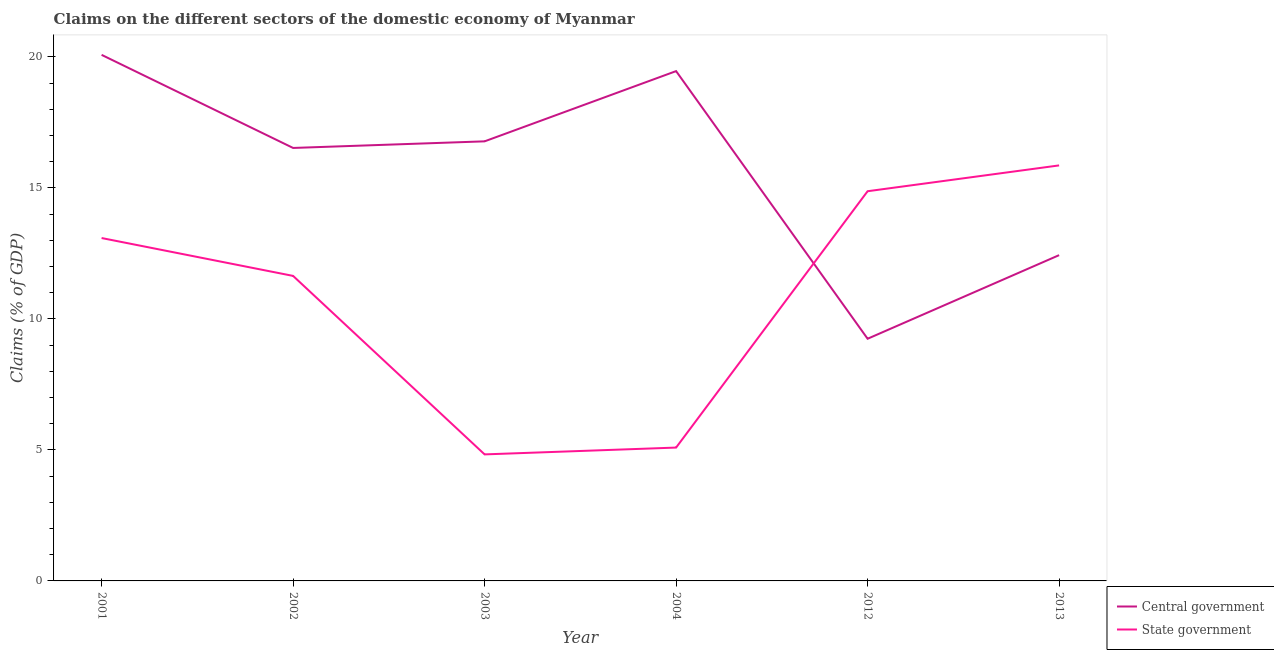Does the line corresponding to claims on state government intersect with the line corresponding to claims on central government?
Keep it short and to the point. Yes. What is the claims on central government in 2001?
Provide a succinct answer. 20.08. Across all years, what is the maximum claims on central government?
Offer a terse response. 20.08. Across all years, what is the minimum claims on state government?
Provide a short and direct response. 4.83. What is the total claims on state government in the graph?
Keep it short and to the point. 65.39. What is the difference between the claims on state government in 2004 and that in 2012?
Provide a succinct answer. -9.79. What is the difference between the claims on state government in 2012 and the claims on central government in 2001?
Your response must be concise. -5.21. What is the average claims on state government per year?
Provide a short and direct response. 10.9. In the year 2012, what is the difference between the claims on state government and claims on central government?
Offer a terse response. 5.63. What is the ratio of the claims on state government in 2003 to that in 2012?
Keep it short and to the point. 0.32. Is the claims on state government in 2002 less than that in 2003?
Your answer should be very brief. No. What is the difference between the highest and the second highest claims on central government?
Offer a very short reply. 0.62. What is the difference between the highest and the lowest claims on central government?
Ensure brevity in your answer.  10.84. In how many years, is the claims on central government greater than the average claims on central government taken over all years?
Ensure brevity in your answer.  4. Is the sum of the claims on central government in 2012 and 2013 greater than the maximum claims on state government across all years?
Provide a short and direct response. Yes. Does the claims on central government monotonically increase over the years?
Your answer should be very brief. No. How many years are there in the graph?
Offer a very short reply. 6. Does the graph contain any zero values?
Give a very brief answer. No. Where does the legend appear in the graph?
Your response must be concise. Bottom right. How are the legend labels stacked?
Your answer should be very brief. Vertical. What is the title of the graph?
Offer a very short reply. Claims on the different sectors of the domestic economy of Myanmar. Does "Current education expenditure" appear as one of the legend labels in the graph?
Offer a terse response. No. What is the label or title of the X-axis?
Provide a short and direct response. Year. What is the label or title of the Y-axis?
Provide a short and direct response. Claims (% of GDP). What is the Claims (% of GDP) of Central government in 2001?
Make the answer very short. 20.08. What is the Claims (% of GDP) of State government in 2001?
Ensure brevity in your answer.  13.09. What is the Claims (% of GDP) of Central government in 2002?
Make the answer very short. 16.53. What is the Claims (% of GDP) of State government in 2002?
Keep it short and to the point. 11.64. What is the Claims (% of GDP) of Central government in 2003?
Provide a short and direct response. 16.78. What is the Claims (% of GDP) in State government in 2003?
Make the answer very short. 4.83. What is the Claims (% of GDP) of Central government in 2004?
Offer a very short reply. 19.46. What is the Claims (% of GDP) of State government in 2004?
Keep it short and to the point. 5.09. What is the Claims (% of GDP) of Central government in 2012?
Make the answer very short. 9.24. What is the Claims (% of GDP) in State government in 2012?
Your answer should be very brief. 14.88. What is the Claims (% of GDP) of Central government in 2013?
Keep it short and to the point. 12.44. What is the Claims (% of GDP) of State government in 2013?
Provide a succinct answer. 15.86. Across all years, what is the maximum Claims (% of GDP) of Central government?
Make the answer very short. 20.08. Across all years, what is the maximum Claims (% of GDP) in State government?
Your answer should be very brief. 15.86. Across all years, what is the minimum Claims (% of GDP) of Central government?
Offer a very short reply. 9.24. Across all years, what is the minimum Claims (% of GDP) of State government?
Offer a terse response. 4.83. What is the total Claims (% of GDP) in Central government in the graph?
Offer a very short reply. 94.53. What is the total Claims (% of GDP) in State government in the graph?
Offer a very short reply. 65.39. What is the difference between the Claims (% of GDP) of Central government in 2001 and that in 2002?
Give a very brief answer. 3.55. What is the difference between the Claims (% of GDP) of State government in 2001 and that in 2002?
Offer a terse response. 1.45. What is the difference between the Claims (% of GDP) of Central government in 2001 and that in 2003?
Your response must be concise. 3.3. What is the difference between the Claims (% of GDP) in State government in 2001 and that in 2003?
Make the answer very short. 8.26. What is the difference between the Claims (% of GDP) of Central government in 2001 and that in 2004?
Keep it short and to the point. 0.62. What is the difference between the Claims (% of GDP) of State government in 2001 and that in 2004?
Your answer should be very brief. 8. What is the difference between the Claims (% of GDP) of Central government in 2001 and that in 2012?
Offer a terse response. 10.84. What is the difference between the Claims (% of GDP) of State government in 2001 and that in 2012?
Ensure brevity in your answer.  -1.79. What is the difference between the Claims (% of GDP) of Central government in 2001 and that in 2013?
Offer a terse response. 7.65. What is the difference between the Claims (% of GDP) in State government in 2001 and that in 2013?
Provide a succinct answer. -2.77. What is the difference between the Claims (% of GDP) of Central government in 2002 and that in 2003?
Keep it short and to the point. -0.25. What is the difference between the Claims (% of GDP) in State government in 2002 and that in 2003?
Provide a succinct answer. 6.81. What is the difference between the Claims (% of GDP) of Central government in 2002 and that in 2004?
Ensure brevity in your answer.  -2.93. What is the difference between the Claims (% of GDP) in State government in 2002 and that in 2004?
Provide a succinct answer. 6.55. What is the difference between the Claims (% of GDP) of Central government in 2002 and that in 2012?
Provide a short and direct response. 7.28. What is the difference between the Claims (% of GDP) in State government in 2002 and that in 2012?
Your answer should be compact. -3.23. What is the difference between the Claims (% of GDP) in Central government in 2002 and that in 2013?
Provide a short and direct response. 4.09. What is the difference between the Claims (% of GDP) of State government in 2002 and that in 2013?
Provide a short and direct response. -4.22. What is the difference between the Claims (% of GDP) of Central government in 2003 and that in 2004?
Your response must be concise. -2.68. What is the difference between the Claims (% of GDP) of State government in 2003 and that in 2004?
Ensure brevity in your answer.  -0.26. What is the difference between the Claims (% of GDP) in Central government in 2003 and that in 2012?
Your response must be concise. 7.54. What is the difference between the Claims (% of GDP) in State government in 2003 and that in 2012?
Your answer should be compact. -10.05. What is the difference between the Claims (% of GDP) in Central government in 2003 and that in 2013?
Your answer should be very brief. 4.34. What is the difference between the Claims (% of GDP) in State government in 2003 and that in 2013?
Offer a terse response. -11.03. What is the difference between the Claims (% of GDP) of Central government in 2004 and that in 2012?
Provide a succinct answer. 10.22. What is the difference between the Claims (% of GDP) of State government in 2004 and that in 2012?
Ensure brevity in your answer.  -9.79. What is the difference between the Claims (% of GDP) in Central government in 2004 and that in 2013?
Keep it short and to the point. 7.03. What is the difference between the Claims (% of GDP) in State government in 2004 and that in 2013?
Keep it short and to the point. -10.77. What is the difference between the Claims (% of GDP) in Central government in 2012 and that in 2013?
Give a very brief answer. -3.19. What is the difference between the Claims (% of GDP) of State government in 2012 and that in 2013?
Make the answer very short. -0.99. What is the difference between the Claims (% of GDP) in Central government in 2001 and the Claims (% of GDP) in State government in 2002?
Give a very brief answer. 8.44. What is the difference between the Claims (% of GDP) of Central government in 2001 and the Claims (% of GDP) of State government in 2003?
Provide a short and direct response. 15.25. What is the difference between the Claims (% of GDP) in Central government in 2001 and the Claims (% of GDP) in State government in 2004?
Provide a succinct answer. 14.99. What is the difference between the Claims (% of GDP) in Central government in 2001 and the Claims (% of GDP) in State government in 2012?
Your answer should be compact. 5.21. What is the difference between the Claims (% of GDP) of Central government in 2001 and the Claims (% of GDP) of State government in 2013?
Ensure brevity in your answer.  4.22. What is the difference between the Claims (% of GDP) of Central government in 2002 and the Claims (% of GDP) of State government in 2003?
Provide a short and direct response. 11.7. What is the difference between the Claims (% of GDP) of Central government in 2002 and the Claims (% of GDP) of State government in 2004?
Your answer should be compact. 11.44. What is the difference between the Claims (% of GDP) of Central government in 2002 and the Claims (% of GDP) of State government in 2012?
Offer a terse response. 1.65. What is the difference between the Claims (% of GDP) in Central government in 2002 and the Claims (% of GDP) in State government in 2013?
Your answer should be compact. 0.67. What is the difference between the Claims (% of GDP) of Central government in 2003 and the Claims (% of GDP) of State government in 2004?
Your response must be concise. 11.69. What is the difference between the Claims (% of GDP) of Central government in 2003 and the Claims (% of GDP) of State government in 2012?
Offer a terse response. 1.9. What is the difference between the Claims (% of GDP) in Central government in 2003 and the Claims (% of GDP) in State government in 2013?
Ensure brevity in your answer.  0.92. What is the difference between the Claims (% of GDP) in Central government in 2004 and the Claims (% of GDP) in State government in 2012?
Make the answer very short. 4.59. What is the difference between the Claims (% of GDP) of Central government in 2004 and the Claims (% of GDP) of State government in 2013?
Your answer should be very brief. 3.6. What is the difference between the Claims (% of GDP) in Central government in 2012 and the Claims (% of GDP) in State government in 2013?
Ensure brevity in your answer.  -6.62. What is the average Claims (% of GDP) in Central government per year?
Keep it short and to the point. 15.76. What is the average Claims (% of GDP) in State government per year?
Keep it short and to the point. 10.9. In the year 2001, what is the difference between the Claims (% of GDP) in Central government and Claims (% of GDP) in State government?
Provide a succinct answer. 6.99. In the year 2002, what is the difference between the Claims (% of GDP) of Central government and Claims (% of GDP) of State government?
Your answer should be compact. 4.88. In the year 2003, what is the difference between the Claims (% of GDP) of Central government and Claims (% of GDP) of State government?
Give a very brief answer. 11.95. In the year 2004, what is the difference between the Claims (% of GDP) of Central government and Claims (% of GDP) of State government?
Keep it short and to the point. 14.37. In the year 2012, what is the difference between the Claims (% of GDP) of Central government and Claims (% of GDP) of State government?
Give a very brief answer. -5.63. In the year 2013, what is the difference between the Claims (% of GDP) of Central government and Claims (% of GDP) of State government?
Your answer should be compact. -3.43. What is the ratio of the Claims (% of GDP) in Central government in 2001 to that in 2002?
Offer a very short reply. 1.22. What is the ratio of the Claims (% of GDP) of State government in 2001 to that in 2002?
Give a very brief answer. 1.12. What is the ratio of the Claims (% of GDP) of Central government in 2001 to that in 2003?
Make the answer very short. 1.2. What is the ratio of the Claims (% of GDP) in State government in 2001 to that in 2003?
Make the answer very short. 2.71. What is the ratio of the Claims (% of GDP) in Central government in 2001 to that in 2004?
Keep it short and to the point. 1.03. What is the ratio of the Claims (% of GDP) in State government in 2001 to that in 2004?
Offer a terse response. 2.57. What is the ratio of the Claims (% of GDP) in Central government in 2001 to that in 2012?
Your answer should be very brief. 2.17. What is the ratio of the Claims (% of GDP) in State government in 2001 to that in 2012?
Offer a very short reply. 0.88. What is the ratio of the Claims (% of GDP) of Central government in 2001 to that in 2013?
Your answer should be compact. 1.61. What is the ratio of the Claims (% of GDP) in State government in 2001 to that in 2013?
Offer a terse response. 0.83. What is the ratio of the Claims (% of GDP) of Central government in 2002 to that in 2003?
Keep it short and to the point. 0.98. What is the ratio of the Claims (% of GDP) of State government in 2002 to that in 2003?
Keep it short and to the point. 2.41. What is the ratio of the Claims (% of GDP) in Central government in 2002 to that in 2004?
Provide a short and direct response. 0.85. What is the ratio of the Claims (% of GDP) of State government in 2002 to that in 2004?
Ensure brevity in your answer.  2.29. What is the ratio of the Claims (% of GDP) in Central government in 2002 to that in 2012?
Your answer should be very brief. 1.79. What is the ratio of the Claims (% of GDP) of State government in 2002 to that in 2012?
Your response must be concise. 0.78. What is the ratio of the Claims (% of GDP) in Central government in 2002 to that in 2013?
Ensure brevity in your answer.  1.33. What is the ratio of the Claims (% of GDP) of State government in 2002 to that in 2013?
Give a very brief answer. 0.73. What is the ratio of the Claims (% of GDP) of Central government in 2003 to that in 2004?
Ensure brevity in your answer.  0.86. What is the ratio of the Claims (% of GDP) in State government in 2003 to that in 2004?
Ensure brevity in your answer.  0.95. What is the ratio of the Claims (% of GDP) in Central government in 2003 to that in 2012?
Ensure brevity in your answer.  1.82. What is the ratio of the Claims (% of GDP) of State government in 2003 to that in 2012?
Keep it short and to the point. 0.32. What is the ratio of the Claims (% of GDP) of Central government in 2003 to that in 2013?
Offer a very short reply. 1.35. What is the ratio of the Claims (% of GDP) in State government in 2003 to that in 2013?
Your response must be concise. 0.3. What is the ratio of the Claims (% of GDP) of Central government in 2004 to that in 2012?
Make the answer very short. 2.11. What is the ratio of the Claims (% of GDP) in State government in 2004 to that in 2012?
Provide a succinct answer. 0.34. What is the ratio of the Claims (% of GDP) of Central government in 2004 to that in 2013?
Keep it short and to the point. 1.56. What is the ratio of the Claims (% of GDP) in State government in 2004 to that in 2013?
Offer a terse response. 0.32. What is the ratio of the Claims (% of GDP) in Central government in 2012 to that in 2013?
Give a very brief answer. 0.74. What is the ratio of the Claims (% of GDP) in State government in 2012 to that in 2013?
Your answer should be compact. 0.94. What is the difference between the highest and the second highest Claims (% of GDP) in Central government?
Provide a succinct answer. 0.62. What is the difference between the highest and the second highest Claims (% of GDP) of State government?
Keep it short and to the point. 0.99. What is the difference between the highest and the lowest Claims (% of GDP) of Central government?
Ensure brevity in your answer.  10.84. What is the difference between the highest and the lowest Claims (% of GDP) of State government?
Your response must be concise. 11.03. 